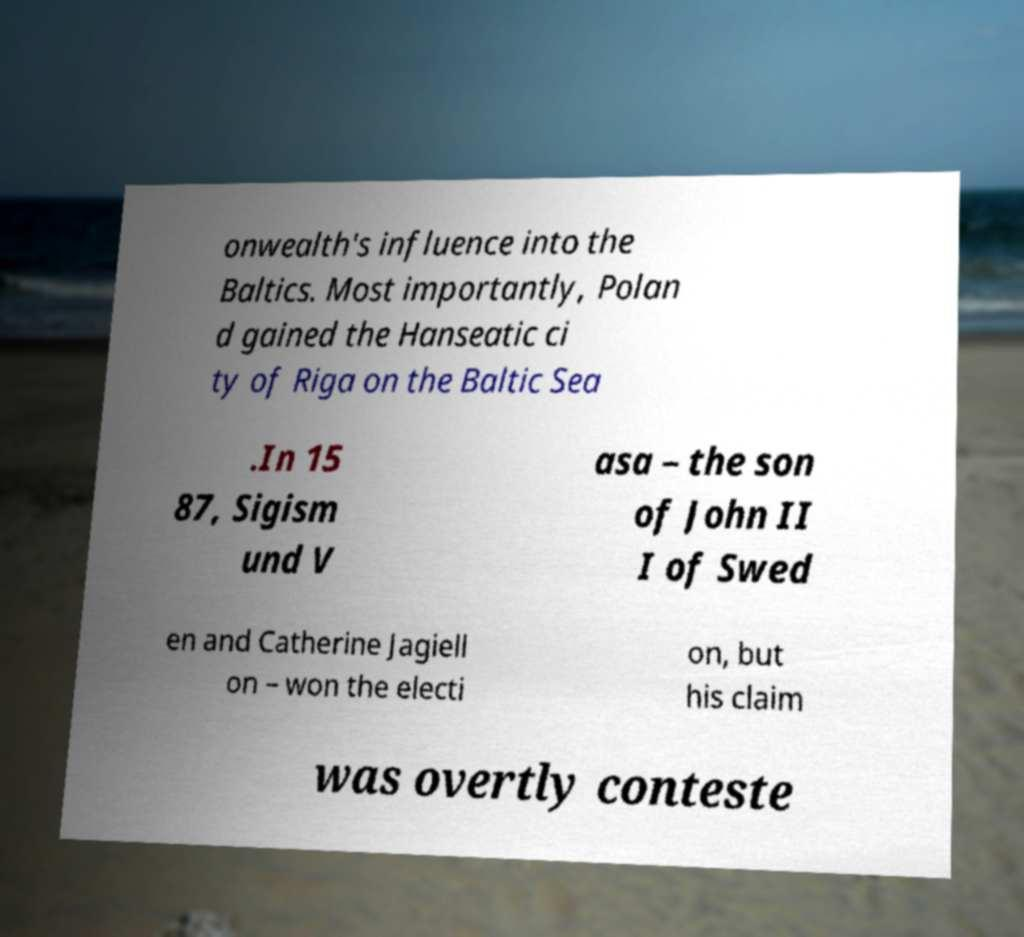For documentation purposes, I need the text within this image transcribed. Could you provide that? onwealth's influence into the Baltics. Most importantly, Polan d gained the Hanseatic ci ty of Riga on the Baltic Sea .In 15 87, Sigism und V asa – the son of John II I of Swed en and Catherine Jagiell on – won the electi on, but his claim was overtly conteste 